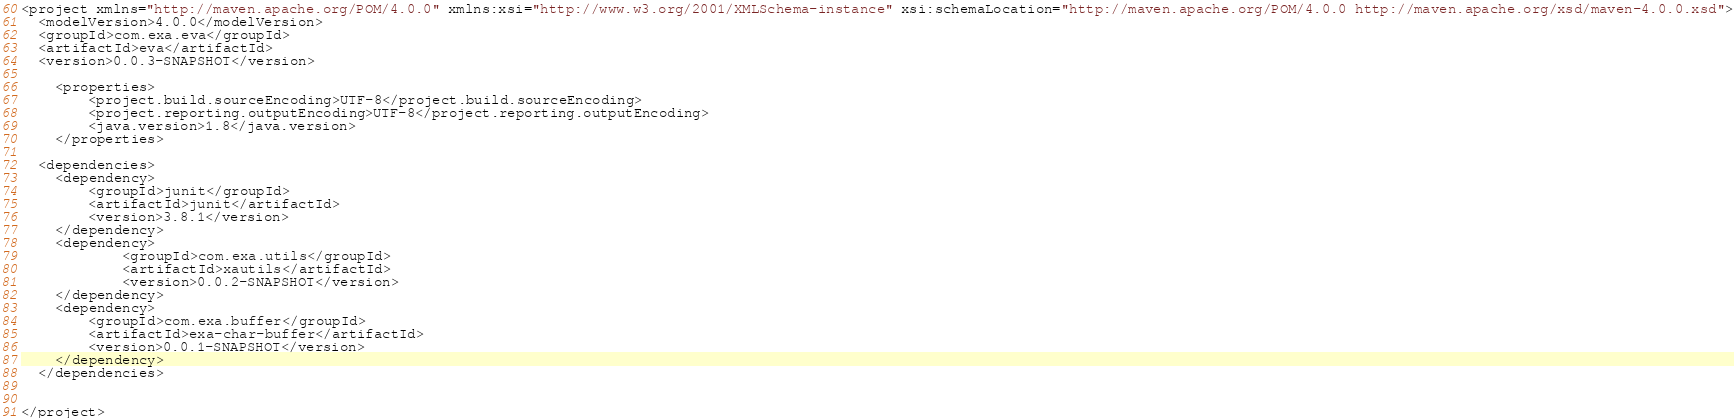<code> <loc_0><loc_0><loc_500><loc_500><_XML_><project xmlns="http://maven.apache.org/POM/4.0.0" xmlns:xsi="http://www.w3.org/2001/XMLSchema-instance" xsi:schemaLocation="http://maven.apache.org/POM/4.0.0 http://maven.apache.org/xsd/maven-4.0.0.xsd">
  <modelVersion>4.0.0</modelVersion>
  <groupId>com.exa.eva</groupId>
  <artifactId>eva</artifactId>
  <version>0.0.3-SNAPSHOT</version>
  
	<properties>
		<project.build.sourceEncoding>UTF-8</project.build.sourceEncoding>
		<project.reporting.outputEncoding>UTF-8</project.reporting.outputEncoding>
		<java.version>1.8</java.version>
	</properties>
	  
  <dependencies>
  	<dependency>
  		<groupId>junit</groupId>
  		<artifactId>junit</artifactId>
  		<version>3.8.1</version>
  	</dependency>
  	<dependency>
			<groupId>com.exa.utils</groupId>
			<artifactId>xautils</artifactId>
			<version>0.0.2-SNAPSHOT</version>
	</dependency>
	<dependency>
		<groupId>com.exa.buffer</groupId>
		<artifactId>exa-char-buffer</artifactId>
		<version>0.0.1-SNAPSHOT</version>
	</dependency>
  </dependencies>
  
  
</project></code> 